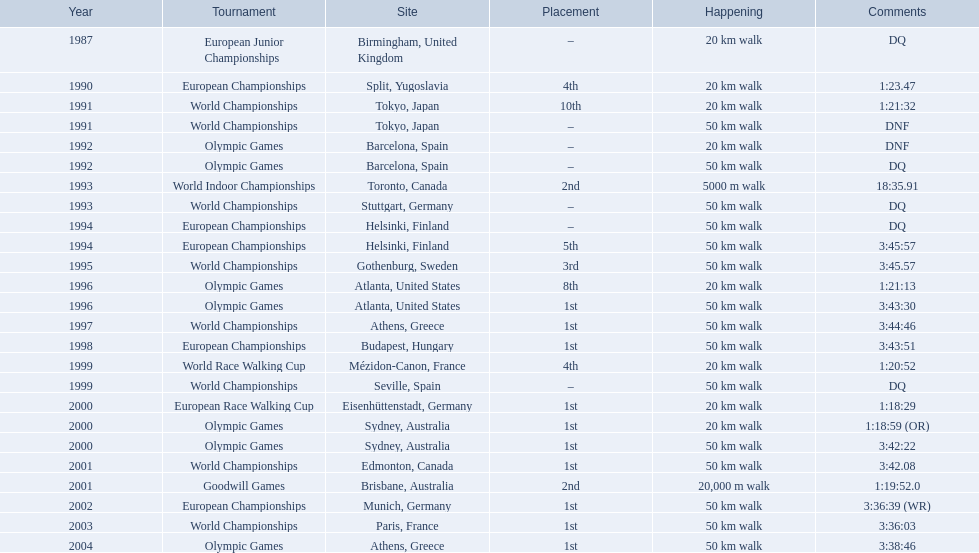In 1990 what position did robert korzeniowski place? 4th. In 1993 what was robert korzeniowski's place in the world indoor championships? 2nd. How long did the 50km walk in 2004 olympic cost? 3:38:46. 